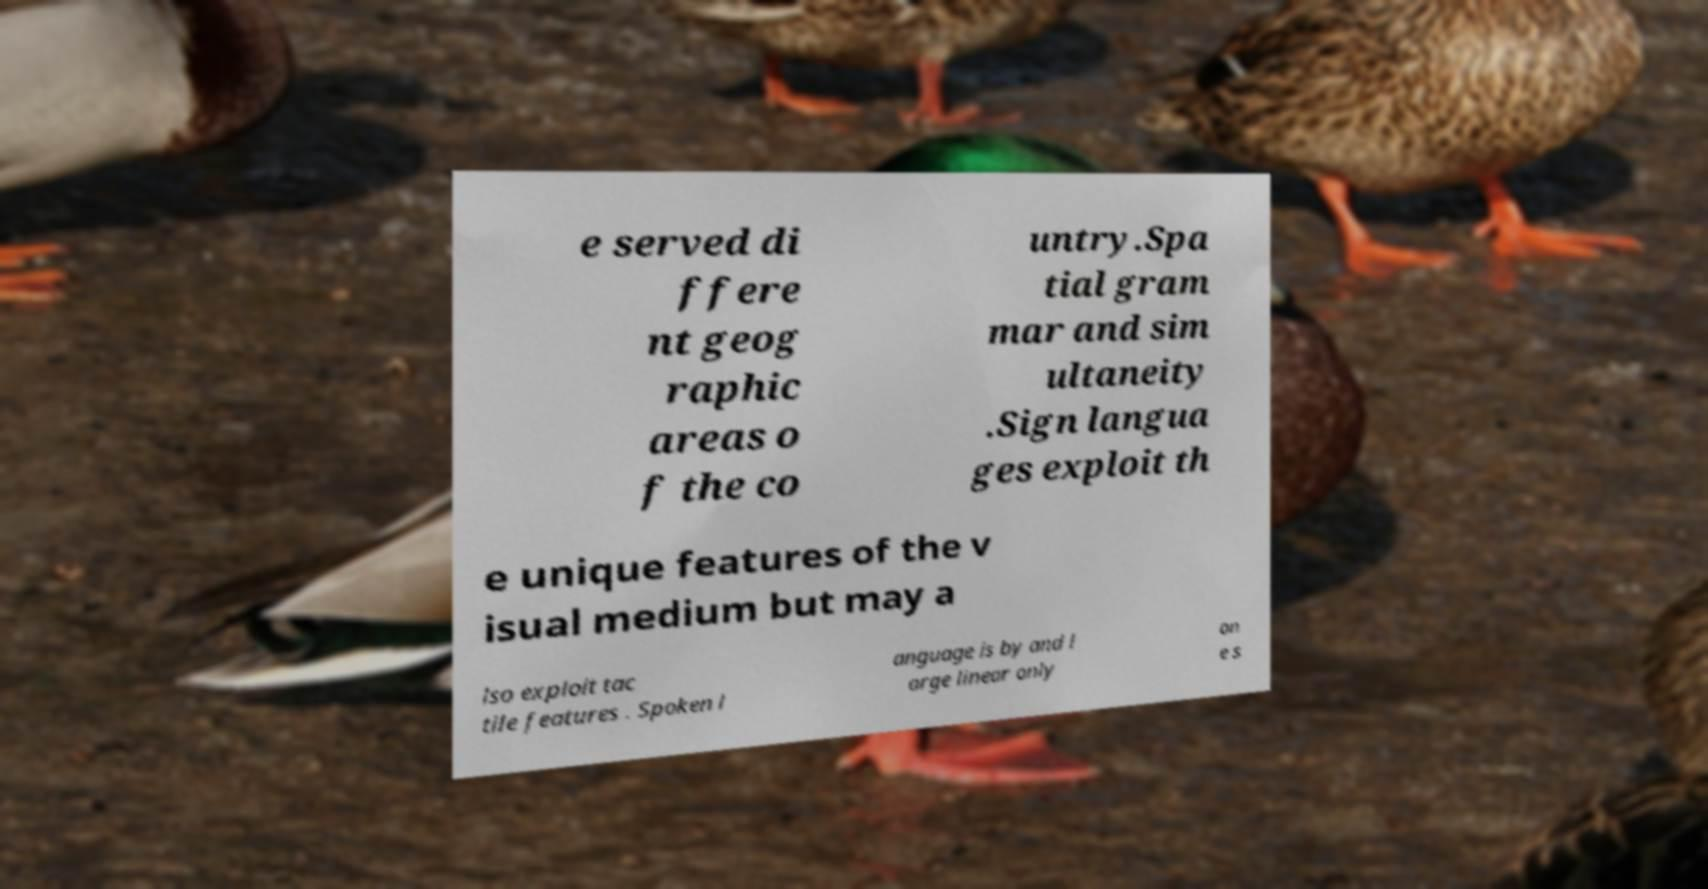What messages or text are displayed in this image? I need them in a readable, typed format. e served di ffere nt geog raphic areas o f the co untry.Spa tial gram mar and sim ultaneity .Sign langua ges exploit th e unique features of the v isual medium but may a lso exploit tac tile features . Spoken l anguage is by and l arge linear only on e s 